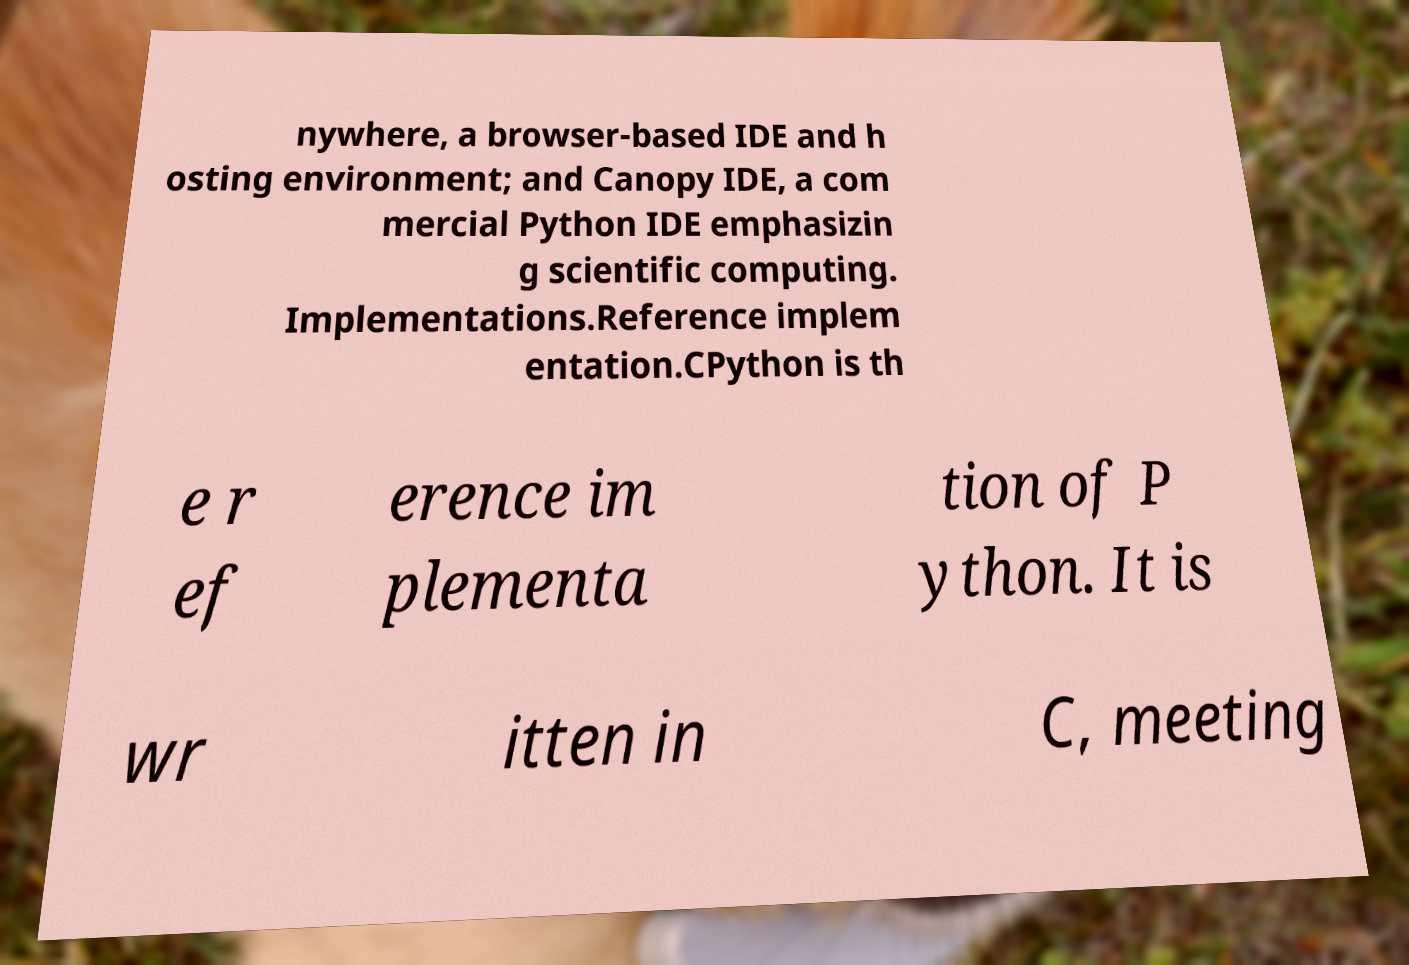Can you read and provide the text displayed in the image?This photo seems to have some interesting text. Can you extract and type it out for me? nywhere, a browser-based IDE and h osting environment; and Canopy IDE, a com mercial Python IDE emphasizin g scientific computing. Implementations.Reference implem entation.CPython is th e r ef erence im plementa tion of P ython. It is wr itten in C, meeting 